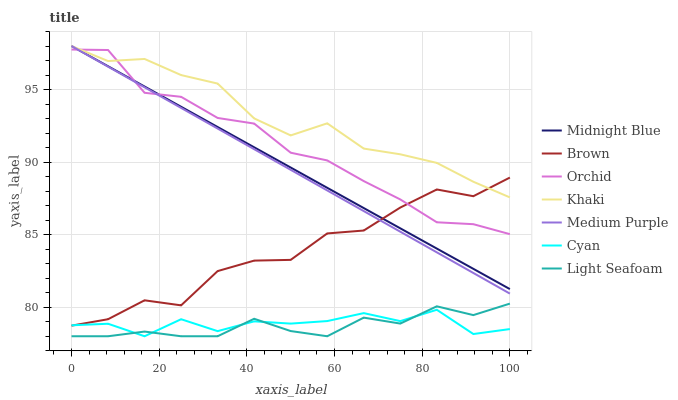Does Light Seafoam have the minimum area under the curve?
Answer yes or no. Yes. Does Khaki have the maximum area under the curve?
Answer yes or no. Yes. Does Midnight Blue have the minimum area under the curve?
Answer yes or no. No. Does Midnight Blue have the maximum area under the curve?
Answer yes or no. No. Is Midnight Blue the smoothest?
Answer yes or no. Yes. Is Brown the roughest?
Answer yes or no. Yes. Is Khaki the smoothest?
Answer yes or no. No. Is Khaki the roughest?
Answer yes or no. No. Does Midnight Blue have the lowest value?
Answer yes or no. No. Does Medium Purple have the highest value?
Answer yes or no. Yes. Does Cyan have the highest value?
Answer yes or no. No. Is Cyan less than Midnight Blue?
Answer yes or no. Yes. Is Midnight Blue greater than Cyan?
Answer yes or no. Yes. Does Midnight Blue intersect Brown?
Answer yes or no. Yes. Is Midnight Blue less than Brown?
Answer yes or no. No. Is Midnight Blue greater than Brown?
Answer yes or no. No. Does Cyan intersect Midnight Blue?
Answer yes or no. No. 